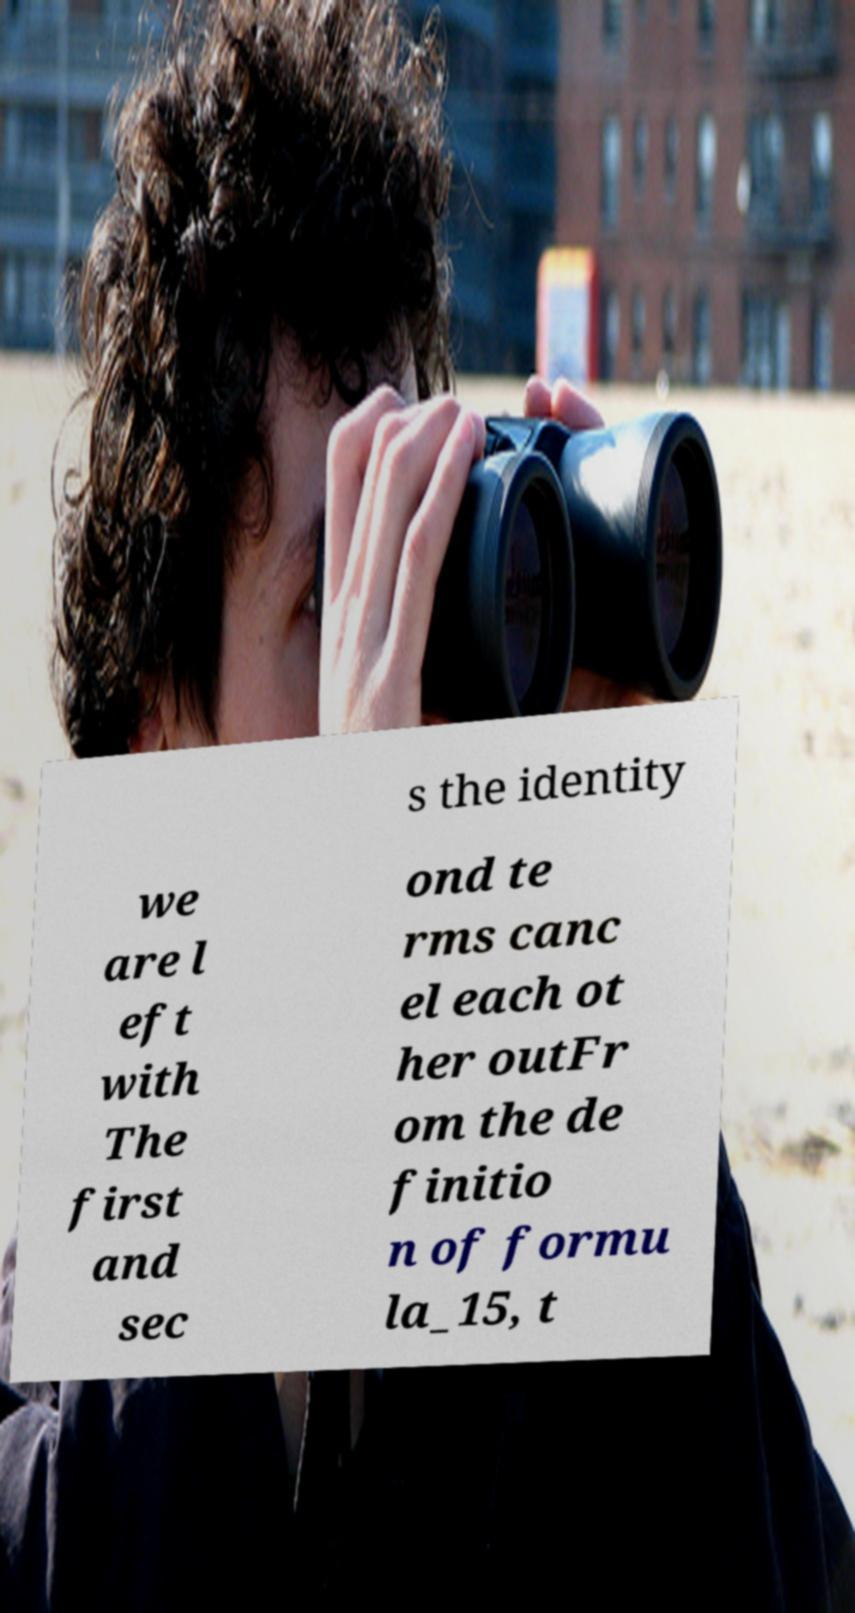Can you accurately transcribe the text from the provided image for me? s the identity we are l eft with The first and sec ond te rms canc el each ot her outFr om the de finitio n of formu la_15, t 